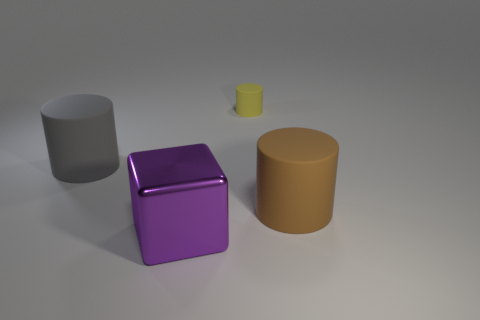Subtract all large matte cylinders. How many cylinders are left? 1 Subtract all yellow cylinders. How many cylinders are left? 2 Subtract 1 cubes. How many cubes are left? 0 Add 1 metal cubes. How many metal cubes are left? 2 Add 3 gray matte cylinders. How many gray matte cylinders exist? 4 Add 1 big brown rubber objects. How many objects exist? 5 Subtract 0 cyan spheres. How many objects are left? 4 Subtract all blocks. How many objects are left? 3 Subtract all yellow cylinders. Subtract all red spheres. How many cylinders are left? 2 Subtract all yellow balls. How many red blocks are left? 0 